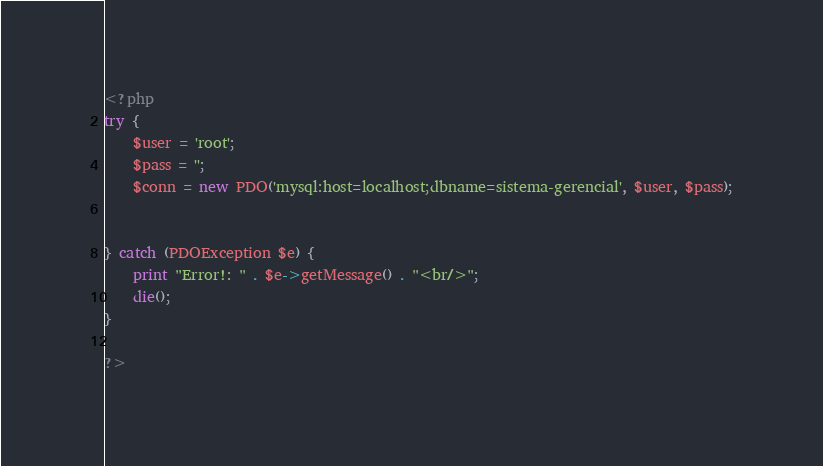<code> <loc_0><loc_0><loc_500><loc_500><_PHP_><?php
try {
    $user = 'root';
    $pass = '';
    $conn = new PDO('mysql:host=localhost;dbname=sistema-gerencial', $user, $pass);


} catch (PDOException $e) {
    print "Error!: " . $e->getMessage() . "<br/>";
    die();
}

?></code> 